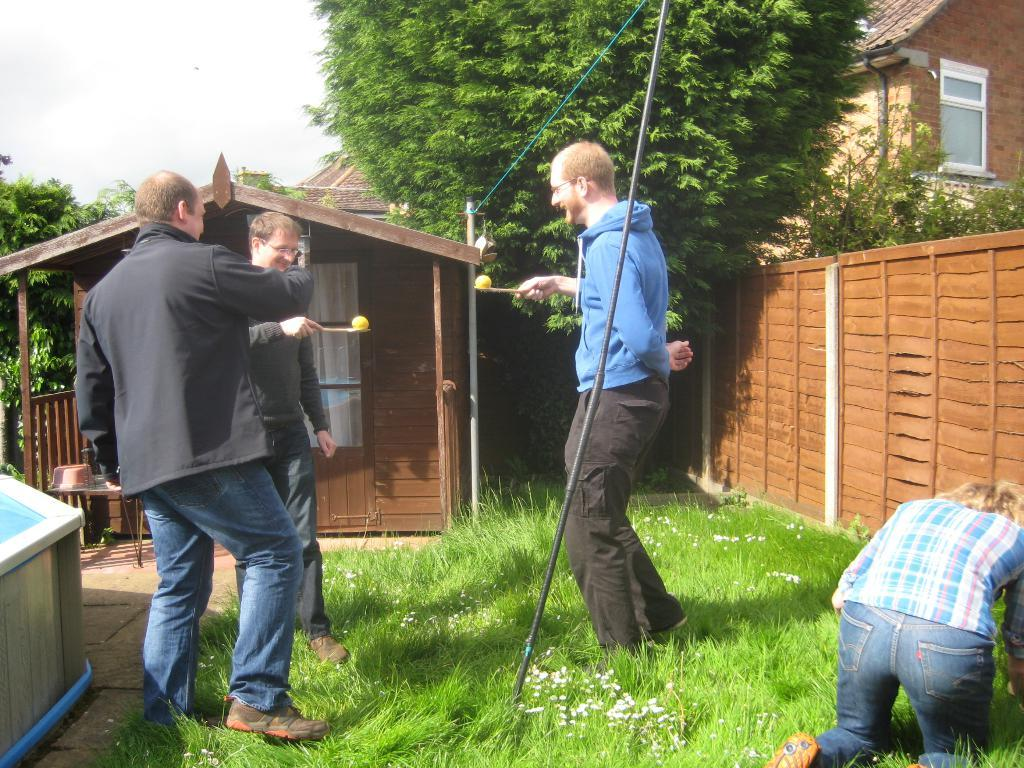What is the primary vegetation covering the land in the image? The land is covered with grass. How many people are present in the image? There are two people in the image. What are the people holding in the image? The people are holding objects with a ball. Can you describe the structures in the image? There are houses with windows in the image. What separates the trees in the image? There is a fence between the trees in the image. What type of produce is being sold at the business in the image? There is no business or produce present in the image. How does the nerve affect the people in the image? There is no mention of a nerve or its effects on the people in the image. 